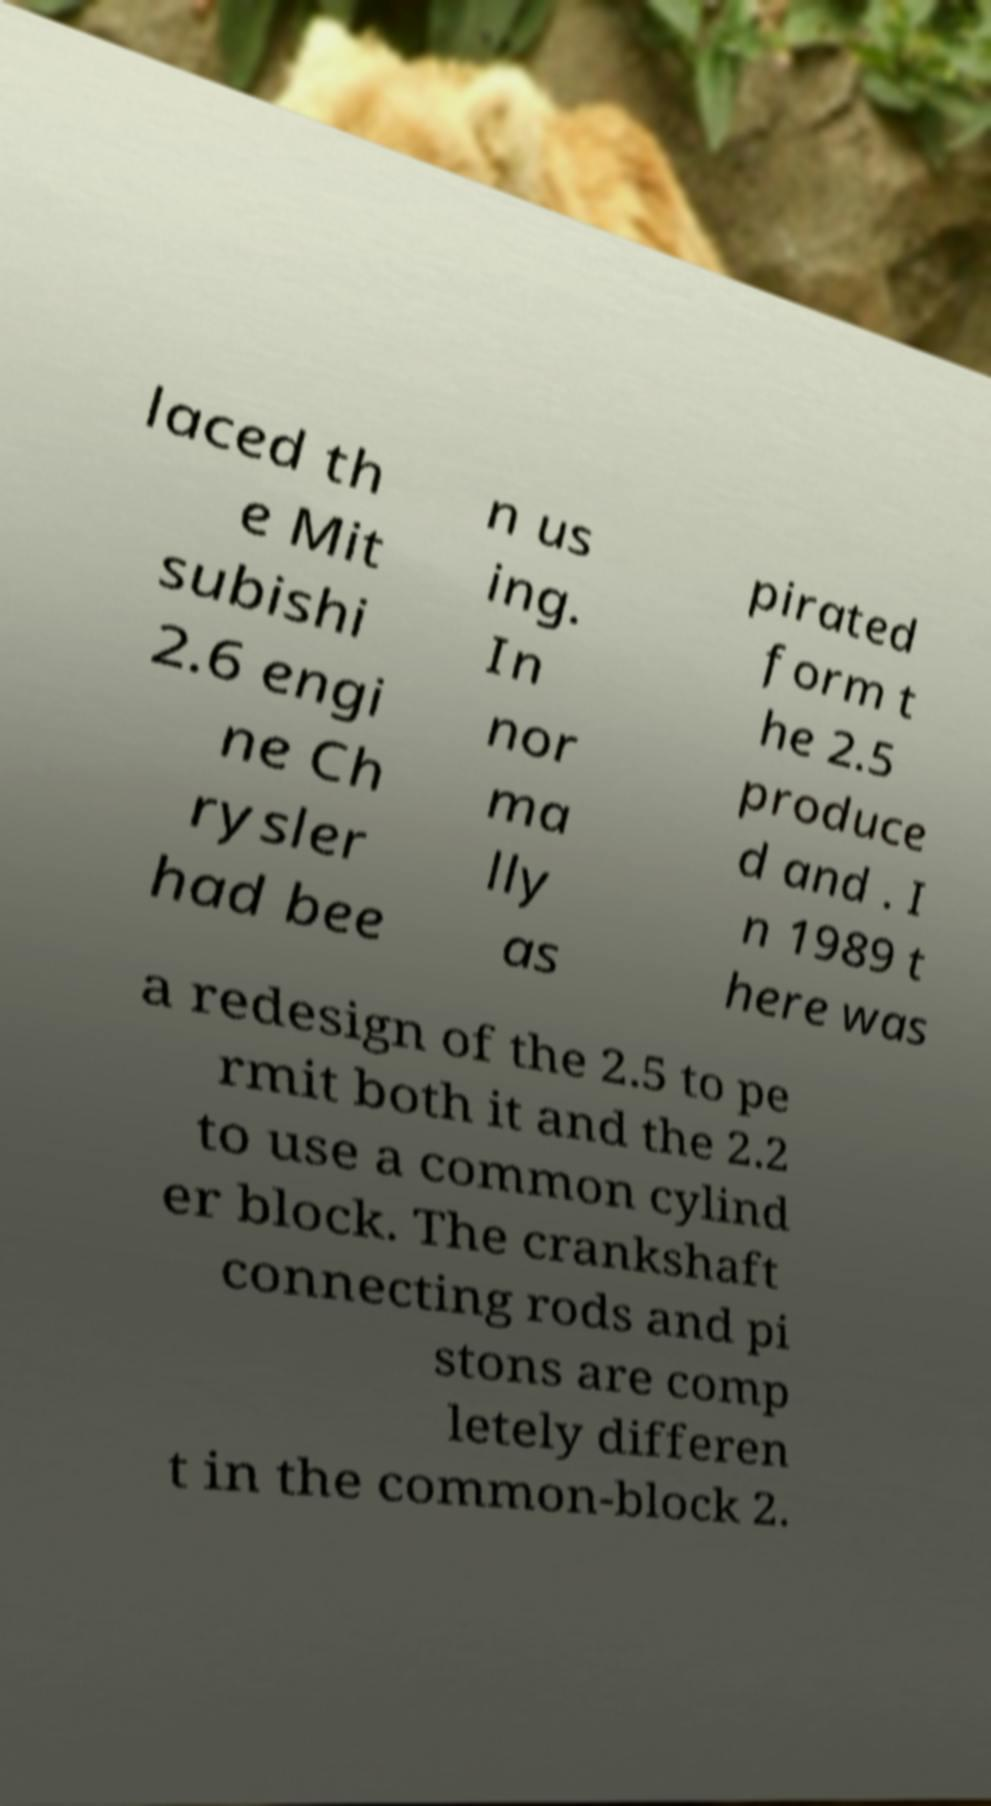What messages or text are displayed in this image? I need them in a readable, typed format. laced th e Mit subishi 2.6 engi ne Ch rysler had bee n us ing. In nor ma lly as pirated form t he 2.5 produce d and . I n 1989 t here was a redesign of the 2.5 to pe rmit both it and the 2.2 to use a common cylind er block. The crankshaft connecting rods and pi stons are comp letely differen t in the common-block 2. 